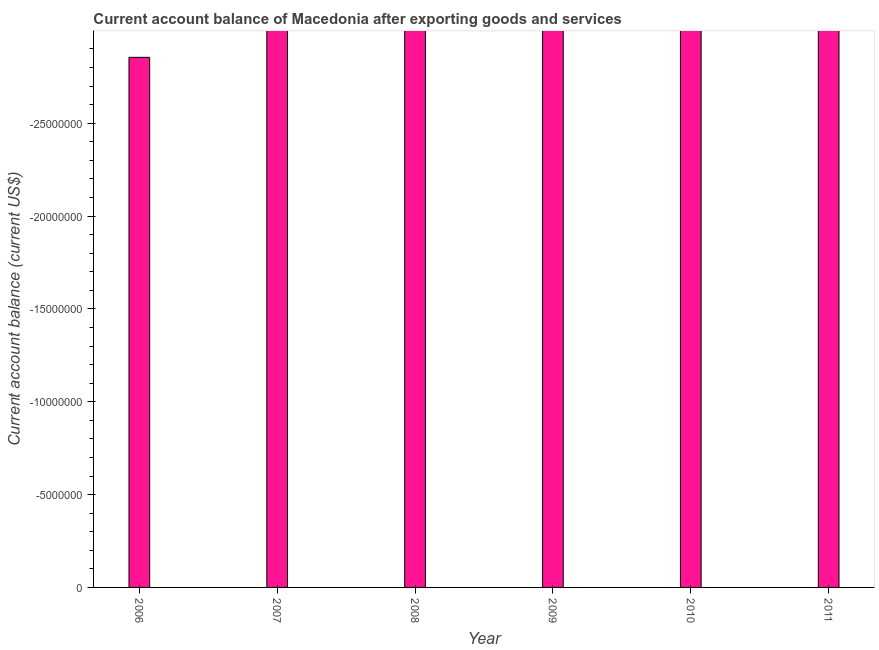What is the title of the graph?
Your answer should be very brief. Current account balance of Macedonia after exporting goods and services. What is the label or title of the X-axis?
Keep it short and to the point. Year. What is the label or title of the Y-axis?
Offer a very short reply. Current account balance (current US$). Across all years, what is the minimum current account balance?
Ensure brevity in your answer.  0. What is the sum of the current account balance?
Ensure brevity in your answer.  0. What is the median current account balance?
Your response must be concise. 0. In how many years, is the current account balance greater than the average current account balance taken over all years?
Keep it short and to the point. 0. How many years are there in the graph?
Offer a terse response. 6. What is the Current account balance (current US$) of 2006?
Offer a very short reply. 0. What is the Current account balance (current US$) in 2007?
Your response must be concise. 0. What is the Current account balance (current US$) in 2008?
Your answer should be compact. 0. What is the Current account balance (current US$) of 2009?
Give a very brief answer. 0. 